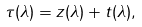Convert formula to latex. <formula><loc_0><loc_0><loc_500><loc_500>\tau ( \lambda ) = z ( \lambda ) + t ( \lambda ) ,</formula> 